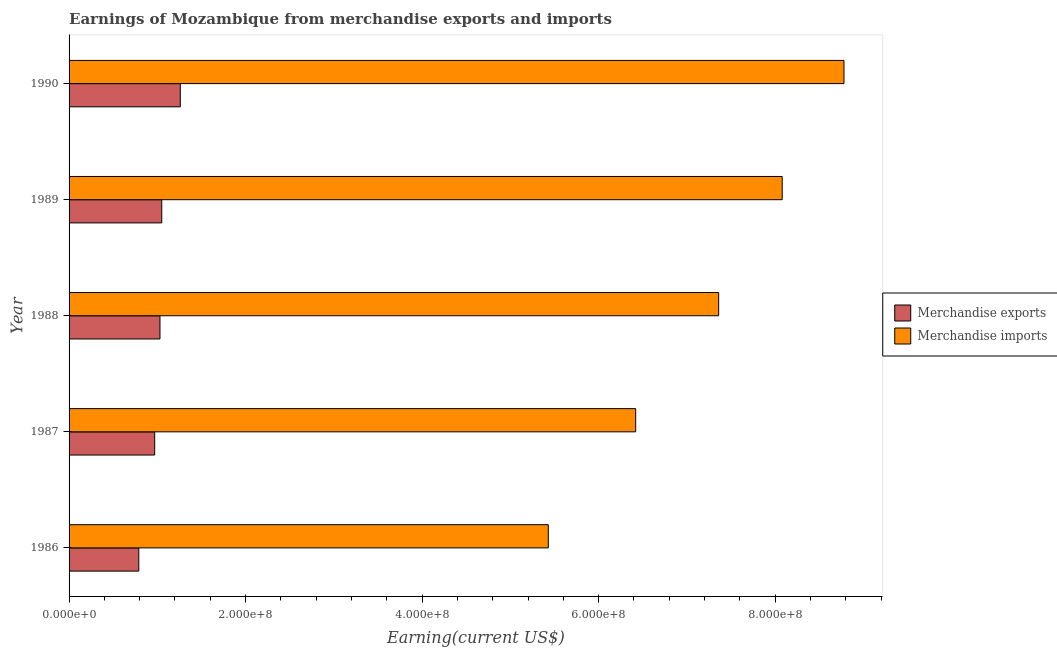How many bars are there on the 1st tick from the top?
Provide a short and direct response. 2. How many bars are there on the 3rd tick from the bottom?
Your response must be concise. 2. What is the label of the 5th group of bars from the top?
Offer a very short reply. 1986. In how many cases, is the number of bars for a given year not equal to the number of legend labels?
Provide a short and direct response. 0. What is the earnings from merchandise exports in 1987?
Your answer should be very brief. 9.70e+07. Across all years, what is the maximum earnings from merchandise exports?
Your answer should be compact. 1.26e+08. Across all years, what is the minimum earnings from merchandise exports?
Provide a short and direct response. 7.90e+07. In which year was the earnings from merchandise exports maximum?
Offer a terse response. 1990. What is the total earnings from merchandise imports in the graph?
Provide a succinct answer. 3.61e+09. What is the difference between the earnings from merchandise exports in 1986 and that in 1987?
Make the answer very short. -1.80e+07. What is the difference between the earnings from merchandise exports in 1988 and the earnings from merchandise imports in 1986?
Ensure brevity in your answer.  -4.40e+08. What is the average earnings from merchandise exports per year?
Ensure brevity in your answer.  1.02e+08. In the year 1990, what is the difference between the earnings from merchandise imports and earnings from merchandise exports?
Offer a terse response. 7.52e+08. What is the ratio of the earnings from merchandise imports in 1988 to that in 1990?
Your response must be concise. 0.84. Is the earnings from merchandise exports in 1989 less than that in 1990?
Offer a terse response. Yes. Is the difference between the earnings from merchandise imports in 1989 and 1990 greater than the difference between the earnings from merchandise exports in 1989 and 1990?
Your answer should be very brief. No. What is the difference between the highest and the second highest earnings from merchandise imports?
Keep it short and to the point. 7.00e+07. What is the difference between the highest and the lowest earnings from merchandise imports?
Provide a succinct answer. 3.35e+08. Is the sum of the earnings from merchandise imports in 1986 and 1988 greater than the maximum earnings from merchandise exports across all years?
Make the answer very short. Yes. What does the 2nd bar from the top in 1987 represents?
Your answer should be compact. Merchandise exports. What does the 2nd bar from the bottom in 1987 represents?
Your response must be concise. Merchandise imports. What is the difference between two consecutive major ticks on the X-axis?
Keep it short and to the point. 2.00e+08. Does the graph contain any zero values?
Provide a succinct answer. No. Where does the legend appear in the graph?
Make the answer very short. Center right. How are the legend labels stacked?
Provide a succinct answer. Vertical. What is the title of the graph?
Offer a terse response. Earnings of Mozambique from merchandise exports and imports. Does "Exports" appear as one of the legend labels in the graph?
Provide a short and direct response. No. What is the label or title of the X-axis?
Provide a succinct answer. Earning(current US$). What is the Earning(current US$) of Merchandise exports in 1986?
Make the answer very short. 7.90e+07. What is the Earning(current US$) of Merchandise imports in 1986?
Give a very brief answer. 5.43e+08. What is the Earning(current US$) in Merchandise exports in 1987?
Keep it short and to the point. 9.70e+07. What is the Earning(current US$) in Merchandise imports in 1987?
Offer a very short reply. 6.42e+08. What is the Earning(current US$) of Merchandise exports in 1988?
Your response must be concise. 1.03e+08. What is the Earning(current US$) in Merchandise imports in 1988?
Give a very brief answer. 7.36e+08. What is the Earning(current US$) in Merchandise exports in 1989?
Offer a terse response. 1.05e+08. What is the Earning(current US$) in Merchandise imports in 1989?
Provide a short and direct response. 8.08e+08. What is the Earning(current US$) in Merchandise exports in 1990?
Your answer should be very brief. 1.26e+08. What is the Earning(current US$) of Merchandise imports in 1990?
Your response must be concise. 8.78e+08. Across all years, what is the maximum Earning(current US$) in Merchandise exports?
Offer a terse response. 1.26e+08. Across all years, what is the maximum Earning(current US$) of Merchandise imports?
Provide a succinct answer. 8.78e+08. Across all years, what is the minimum Earning(current US$) of Merchandise exports?
Keep it short and to the point. 7.90e+07. Across all years, what is the minimum Earning(current US$) in Merchandise imports?
Offer a terse response. 5.43e+08. What is the total Earning(current US$) in Merchandise exports in the graph?
Your response must be concise. 5.10e+08. What is the total Earning(current US$) of Merchandise imports in the graph?
Offer a terse response. 3.61e+09. What is the difference between the Earning(current US$) of Merchandise exports in 1986 and that in 1987?
Keep it short and to the point. -1.80e+07. What is the difference between the Earning(current US$) in Merchandise imports in 1986 and that in 1987?
Make the answer very short. -9.90e+07. What is the difference between the Earning(current US$) of Merchandise exports in 1986 and that in 1988?
Provide a succinct answer. -2.40e+07. What is the difference between the Earning(current US$) in Merchandise imports in 1986 and that in 1988?
Your response must be concise. -1.93e+08. What is the difference between the Earning(current US$) in Merchandise exports in 1986 and that in 1989?
Your answer should be compact. -2.60e+07. What is the difference between the Earning(current US$) in Merchandise imports in 1986 and that in 1989?
Offer a terse response. -2.65e+08. What is the difference between the Earning(current US$) of Merchandise exports in 1986 and that in 1990?
Make the answer very short. -4.70e+07. What is the difference between the Earning(current US$) of Merchandise imports in 1986 and that in 1990?
Keep it short and to the point. -3.35e+08. What is the difference between the Earning(current US$) of Merchandise exports in 1987 and that in 1988?
Your answer should be very brief. -6.00e+06. What is the difference between the Earning(current US$) in Merchandise imports in 1987 and that in 1988?
Your response must be concise. -9.40e+07. What is the difference between the Earning(current US$) of Merchandise exports in 1987 and that in 1989?
Offer a very short reply. -8.00e+06. What is the difference between the Earning(current US$) of Merchandise imports in 1987 and that in 1989?
Ensure brevity in your answer.  -1.66e+08. What is the difference between the Earning(current US$) of Merchandise exports in 1987 and that in 1990?
Offer a very short reply. -2.90e+07. What is the difference between the Earning(current US$) of Merchandise imports in 1987 and that in 1990?
Provide a succinct answer. -2.36e+08. What is the difference between the Earning(current US$) of Merchandise imports in 1988 and that in 1989?
Your answer should be compact. -7.20e+07. What is the difference between the Earning(current US$) of Merchandise exports in 1988 and that in 1990?
Make the answer very short. -2.30e+07. What is the difference between the Earning(current US$) of Merchandise imports in 1988 and that in 1990?
Ensure brevity in your answer.  -1.42e+08. What is the difference between the Earning(current US$) in Merchandise exports in 1989 and that in 1990?
Offer a very short reply. -2.10e+07. What is the difference between the Earning(current US$) of Merchandise imports in 1989 and that in 1990?
Give a very brief answer. -7.00e+07. What is the difference between the Earning(current US$) in Merchandise exports in 1986 and the Earning(current US$) in Merchandise imports in 1987?
Make the answer very short. -5.63e+08. What is the difference between the Earning(current US$) in Merchandise exports in 1986 and the Earning(current US$) in Merchandise imports in 1988?
Offer a terse response. -6.57e+08. What is the difference between the Earning(current US$) of Merchandise exports in 1986 and the Earning(current US$) of Merchandise imports in 1989?
Your response must be concise. -7.29e+08. What is the difference between the Earning(current US$) of Merchandise exports in 1986 and the Earning(current US$) of Merchandise imports in 1990?
Provide a short and direct response. -7.99e+08. What is the difference between the Earning(current US$) of Merchandise exports in 1987 and the Earning(current US$) of Merchandise imports in 1988?
Ensure brevity in your answer.  -6.39e+08. What is the difference between the Earning(current US$) in Merchandise exports in 1987 and the Earning(current US$) in Merchandise imports in 1989?
Offer a very short reply. -7.11e+08. What is the difference between the Earning(current US$) in Merchandise exports in 1987 and the Earning(current US$) in Merchandise imports in 1990?
Provide a short and direct response. -7.81e+08. What is the difference between the Earning(current US$) of Merchandise exports in 1988 and the Earning(current US$) of Merchandise imports in 1989?
Your answer should be very brief. -7.05e+08. What is the difference between the Earning(current US$) of Merchandise exports in 1988 and the Earning(current US$) of Merchandise imports in 1990?
Provide a succinct answer. -7.75e+08. What is the difference between the Earning(current US$) of Merchandise exports in 1989 and the Earning(current US$) of Merchandise imports in 1990?
Your answer should be very brief. -7.73e+08. What is the average Earning(current US$) of Merchandise exports per year?
Offer a very short reply. 1.02e+08. What is the average Earning(current US$) of Merchandise imports per year?
Give a very brief answer. 7.21e+08. In the year 1986, what is the difference between the Earning(current US$) in Merchandise exports and Earning(current US$) in Merchandise imports?
Your answer should be compact. -4.64e+08. In the year 1987, what is the difference between the Earning(current US$) of Merchandise exports and Earning(current US$) of Merchandise imports?
Your answer should be compact. -5.45e+08. In the year 1988, what is the difference between the Earning(current US$) in Merchandise exports and Earning(current US$) in Merchandise imports?
Offer a very short reply. -6.33e+08. In the year 1989, what is the difference between the Earning(current US$) of Merchandise exports and Earning(current US$) of Merchandise imports?
Your answer should be compact. -7.03e+08. In the year 1990, what is the difference between the Earning(current US$) in Merchandise exports and Earning(current US$) in Merchandise imports?
Ensure brevity in your answer.  -7.52e+08. What is the ratio of the Earning(current US$) of Merchandise exports in 1986 to that in 1987?
Your response must be concise. 0.81. What is the ratio of the Earning(current US$) in Merchandise imports in 1986 to that in 1987?
Keep it short and to the point. 0.85. What is the ratio of the Earning(current US$) in Merchandise exports in 1986 to that in 1988?
Provide a short and direct response. 0.77. What is the ratio of the Earning(current US$) of Merchandise imports in 1986 to that in 1988?
Offer a very short reply. 0.74. What is the ratio of the Earning(current US$) of Merchandise exports in 1986 to that in 1989?
Keep it short and to the point. 0.75. What is the ratio of the Earning(current US$) of Merchandise imports in 1986 to that in 1989?
Give a very brief answer. 0.67. What is the ratio of the Earning(current US$) of Merchandise exports in 1986 to that in 1990?
Your response must be concise. 0.63. What is the ratio of the Earning(current US$) in Merchandise imports in 1986 to that in 1990?
Provide a succinct answer. 0.62. What is the ratio of the Earning(current US$) in Merchandise exports in 1987 to that in 1988?
Keep it short and to the point. 0.94. What is the ratio of the Earning(current US$) of Merchandise imports in 1987 to that in 1988?
Offer a very short reply. 0.87. What is the ratio of the Earning(current US$) of Merchandise exports in 1987 to that in 1989?
Offer a very short reply. 0.92. What is the ratio of the Earning(current US$) of Merchandise imports in 1987 to that in 1989?
Your response must be concise. 0.79. What is the ratio of the Earning(current US$) in Merchandise exports in 1987 to that in 1990?
Offer a very short reply. 0.77. What is the ratio of the Earning(current US$) in Merchandise imports in 1987 to that in 1990?
Provide a short and direct response. 0.73. What is the ratio of the Earning(current US$) of Merchandise exports in 1988 to that in 1989?
Make the answer very short. 0.98. What is the ratio of the Earning(current US$) of Merchandise imports in 1988 to that in 1989?
Provide a succinct answer. 0.91. What is the ratio of the Earning(current US$) in Merchandise exports in 1988 to that in 1990?
Your answer should be very brief. 0.82. What is the ratio of the Earning(current US$) of Merchandise imports in 1988 to that in 1990?
Ensure brevity in your answer.  0.84. What is the ratio of the Earning(current US$) in Merchandise exports in 1989 to that in 1990?
Provide a succinct answer. 0.83. What is the ratio of the Earning(current US$) of Merchandise imports in 1989 to that in 1990?
Offer a very short reply. 0.92. What is the difference between the highest and the second highest Earning(current US$) of Merchandise exports?
Your response must be concise. 2.10e+07. What is the difference between the highest and the second highest Earning(current US$) in Merchandise imports?
Offer a very short reply. 7.00e+07. What is the difference between the highest and the lowest Earning(current US$) of Merchandise exports?
Offer a terse response. 4.70e+07. What is the difference between the highest and the lowest Earning(current US$) in Merchandise imports?
Provide a succinct answer. 3.35e+08. 